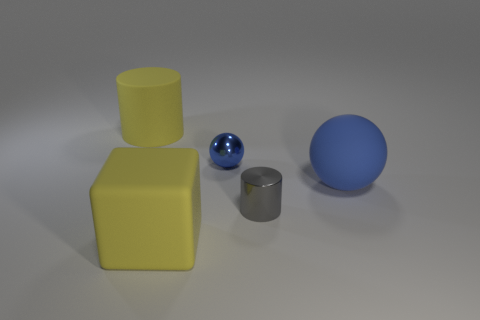Add 3 tiny blue objects. How many objects exist? 8 Subtract all yellow cylinders. How many cylinders are left? 1 Subtract all balls. How many objects are left? 3 Subtract 1 balls. How many balls are left? 1 Subtract all brown balls. How many gray cylinders are left? 1 Subtract all large blue cylinders. Subtract all big spheres. How many objects are left? 4 Add 2 yellow cylinders. How many yellow cylinders are left? 3 Add 3 big brown things. How many big brown things exist? 3 Subtract 2 blue spheres. How many objects are left? 3 Subtract all cyan cylinders. Subtract all red balls. How many cylinders are left? 2 